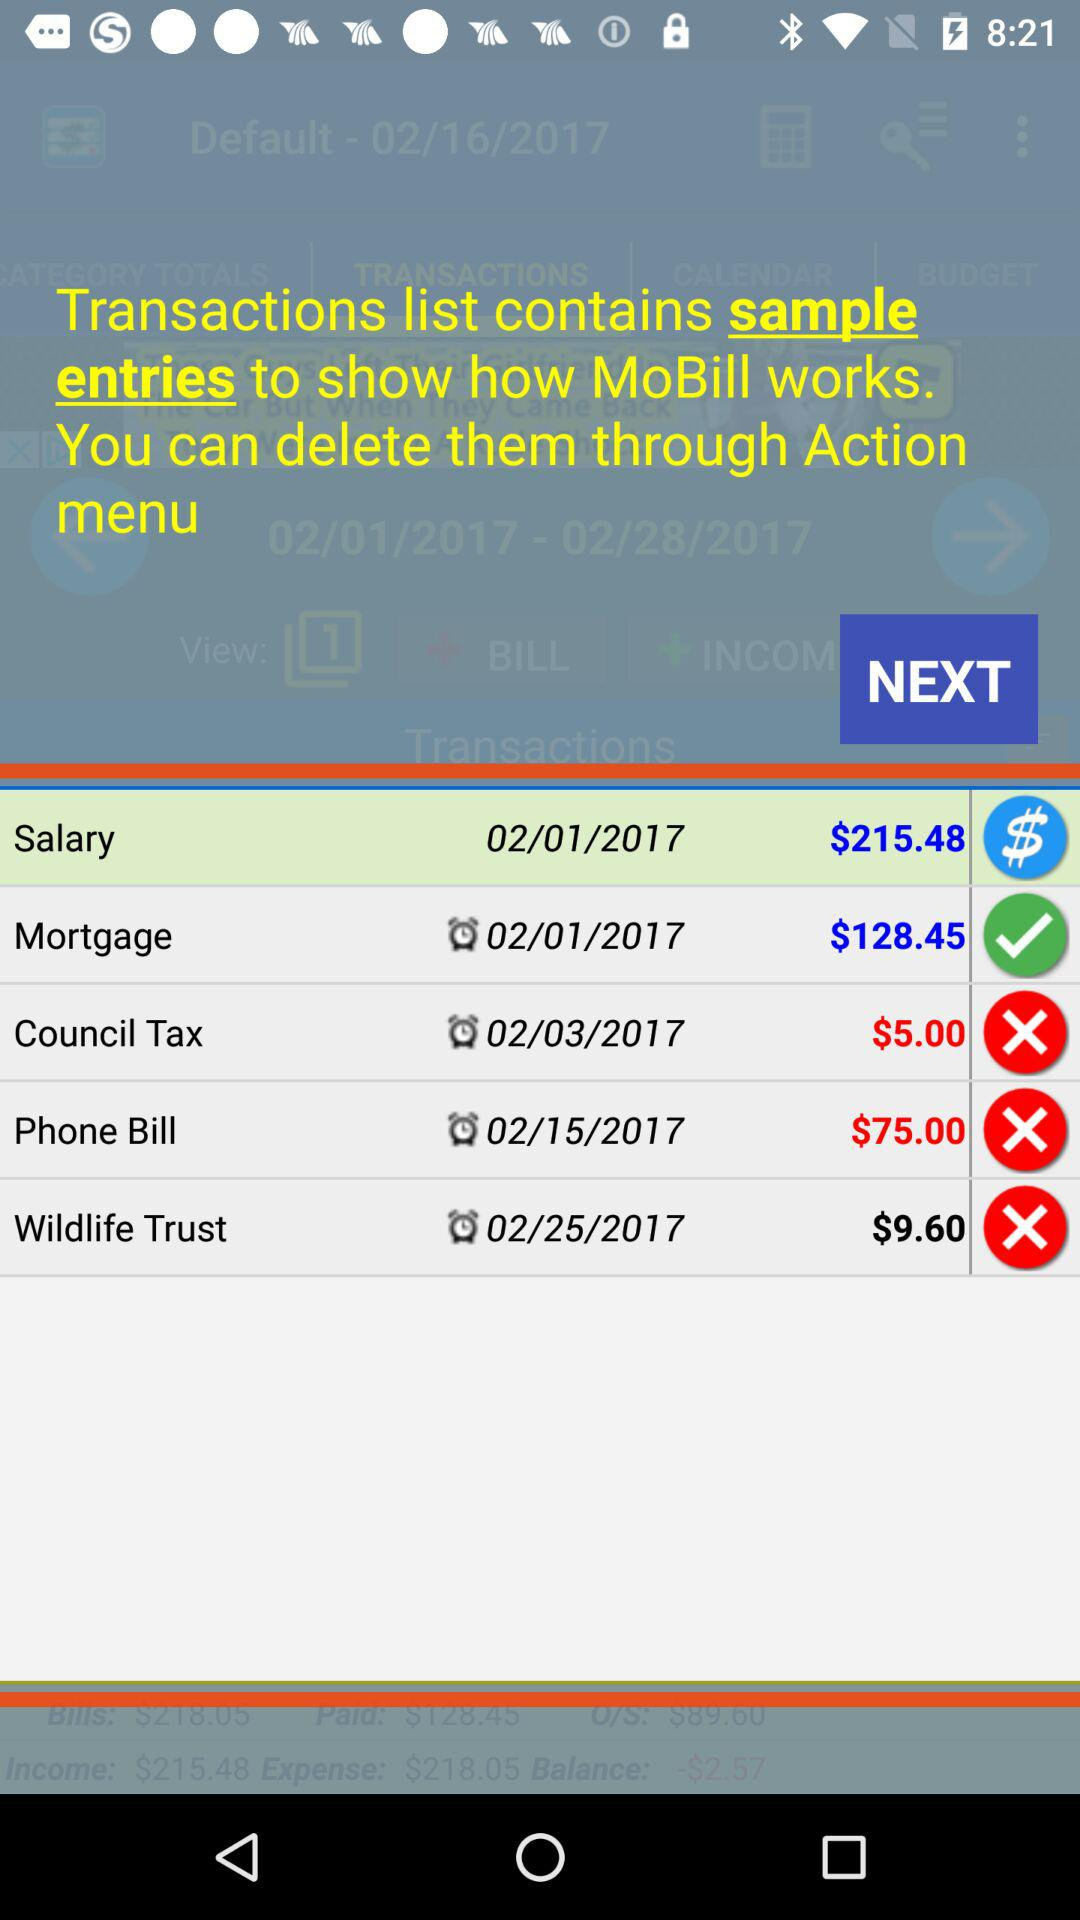Which option costs $5.00? Cost of "Council Tax" is $5. 